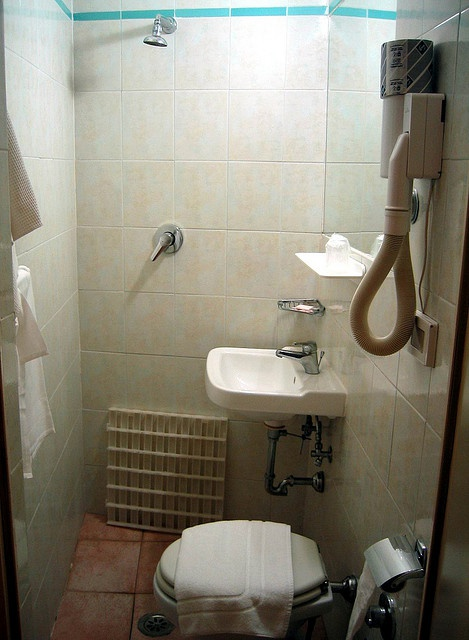Describe the objects in this image and their specific colors. I can see toilet in gray, darkgray, and black tones, hair drier in gray and black tones, and sink in gray, lightgray, and darkgray tones in this image. 